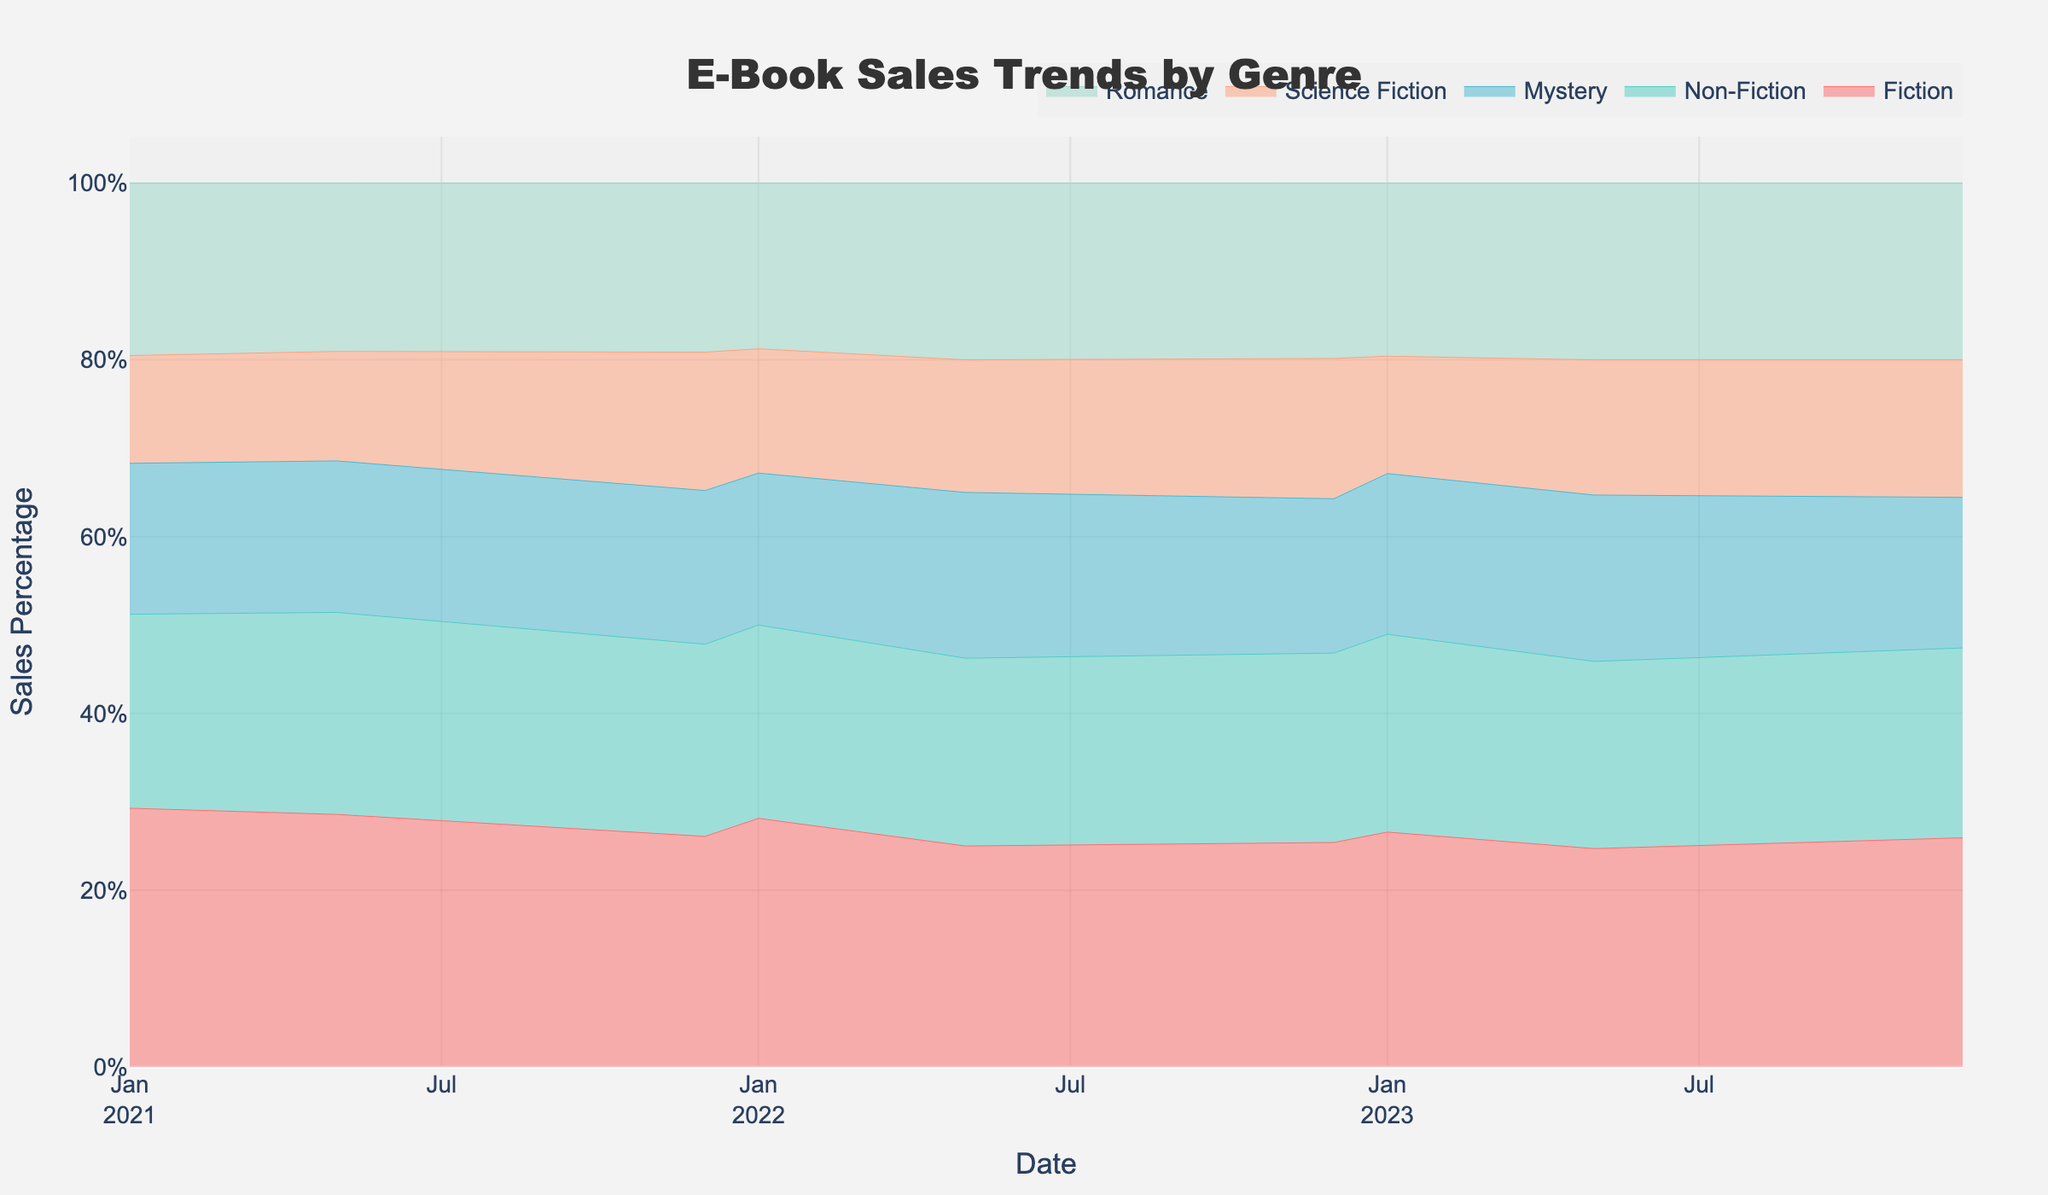What is the title of the graph? The title is usually found at the top of the graph and denotes the main theme of the visualized data. The title here is "E-Book Sales Trends by Genre."
Answer: E-Book Sales Trends by Genre What does the y-axis represent? By looking at the y-axis label, it is apparent that it shows the percentage of sales each genre contributes to total sales over time.
Answer: Sales Percentage Which genre had the highest sales in December 2021? To identify this, look at the stream graph section for December 2021. The tallest stack during this month represents Fiction, indicating it had the highest sales.
Answer: Fiction How do sales trends for Non-Fiction change from January 2021 to December 2023? Observing the Non-Fiction area across the graph from January 2021 to December 2023 shows an increase in sales with peaks in each December and subsequent falls, indicating that Non-Fiction sales fluctuate.
Answer: Peaks in Decembers and rises overall What pattern is evident during the holiday seasons? Looking at each December, there are significant spikes in sales across all genres, showing increased sales during holiday seasons.
Answer: Sales spikes Which genres show a noticeable peak in sales during December 2021? Checking the stream graph area around December 2021, all genres show peaks, but Fiction, Non-Fiction, Mystery, and Romance especially stand out.
Answer: Fiction, Non-Fiction, Mystery, Romance How did Romance genre sales in January 2022 compare to May 2022? By comparing the heights of the Romance stack in January 2022 and May 2022, it is clear that May saw an increase in sales compared to January.
Answer: Increased What general trend is evident in Science Fiction sales over time? Tracking the Science Fiction genre from the left to the right of the graph reveals an overall increase in sales, maintaining some consistency with slight peaks.
Answer: Increasing trend Which genre shows the least variation in sales across different dates? Science Fiction shows the least fluctuation with a more consistent stream width compared to other genres.
Answer: Science Fiction Is there a genre that consistently peaks higher than others? By comparing the peaks of the different genres throughout the timeline, Fiction often peaks higher than the others such as during each December period.
Answer: Fiction 